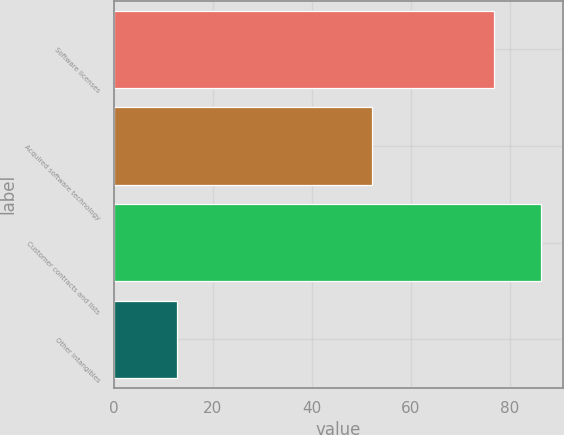Convert chart. <chart><loc_0><loc_0><loc_500><loc_500><bar_chart><fcel>Software licenses<fcel>Acquired software technology<fcel>Customer contracts and lists<fcel>Other intangibles<nl><fcel>76.7<fcel>52.1<fcel>86.3<fcel>12.7<nl></chart> 